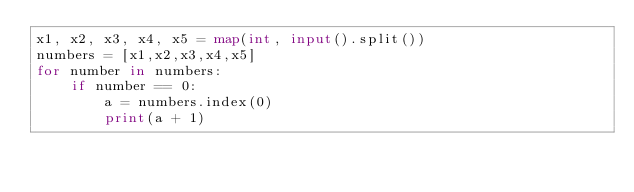Convert code to text. <code><loc_0><loc_0><loc_500><loc_500><_Python_>x1, x2, x3, x4, x5 = map(int, input().split())
numbers = [x1,x2,x3,x4,x5]
for number in numbers:
    if number == 0:
        a = numbers.index(0)
        print(a + 1)
</code> 